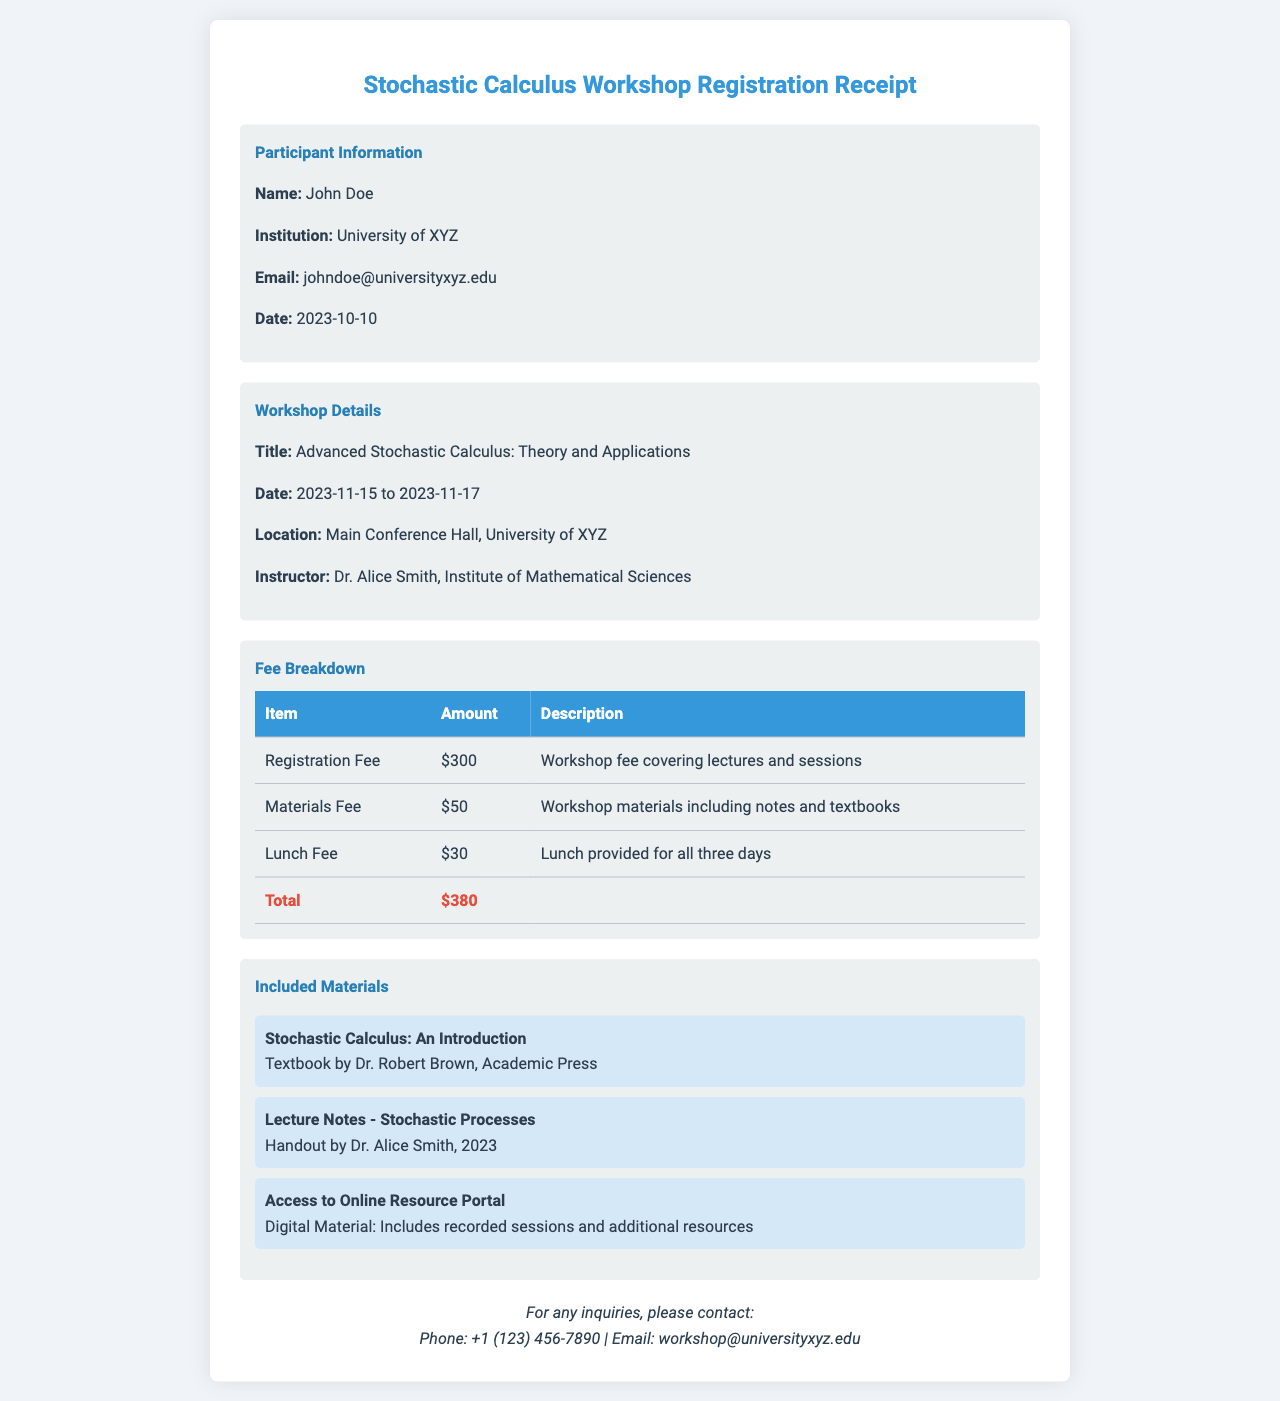What is the participant's name? The participant's name is provided under the section for participant information.
Answer: John Doe What is the total fee for the workshop? The total fee is calculated from the breakdown of fees listed in the document.
Answer: $380 Who is the instructor for the workshop? The instructor's name is listed in the workshop details section.
Answer: Dr. Alice Smith What are the dates of the workshop? The workshop dates are specified in the workshop details section.
Answer: 2023-11-15 to 2023-11-17 What materials are included in the workshop? The included materials are listed in a section specifically for workshop materials.
Answer: Stochastic Calculus: An Introduction, Lecture Notes - Stochastic Processes, Access to Online Resource Portal How much is the Materials Fee? The Materials Fee amount is provided in the fee breakdown table.
Answer: $50 What is the location of the workshop? The location is specified in the workshop details section of the document.
Answer: Main Conference Hall, University of XYZ What is the contact email for inquiries? The contact email is mentioned at the bottom of the receipt for any inquiries.
Answer: workshop@universityxyz.edu What type of event is this receipt for? The type of event is identified in the title of the receipt.
Answer: Workshop 